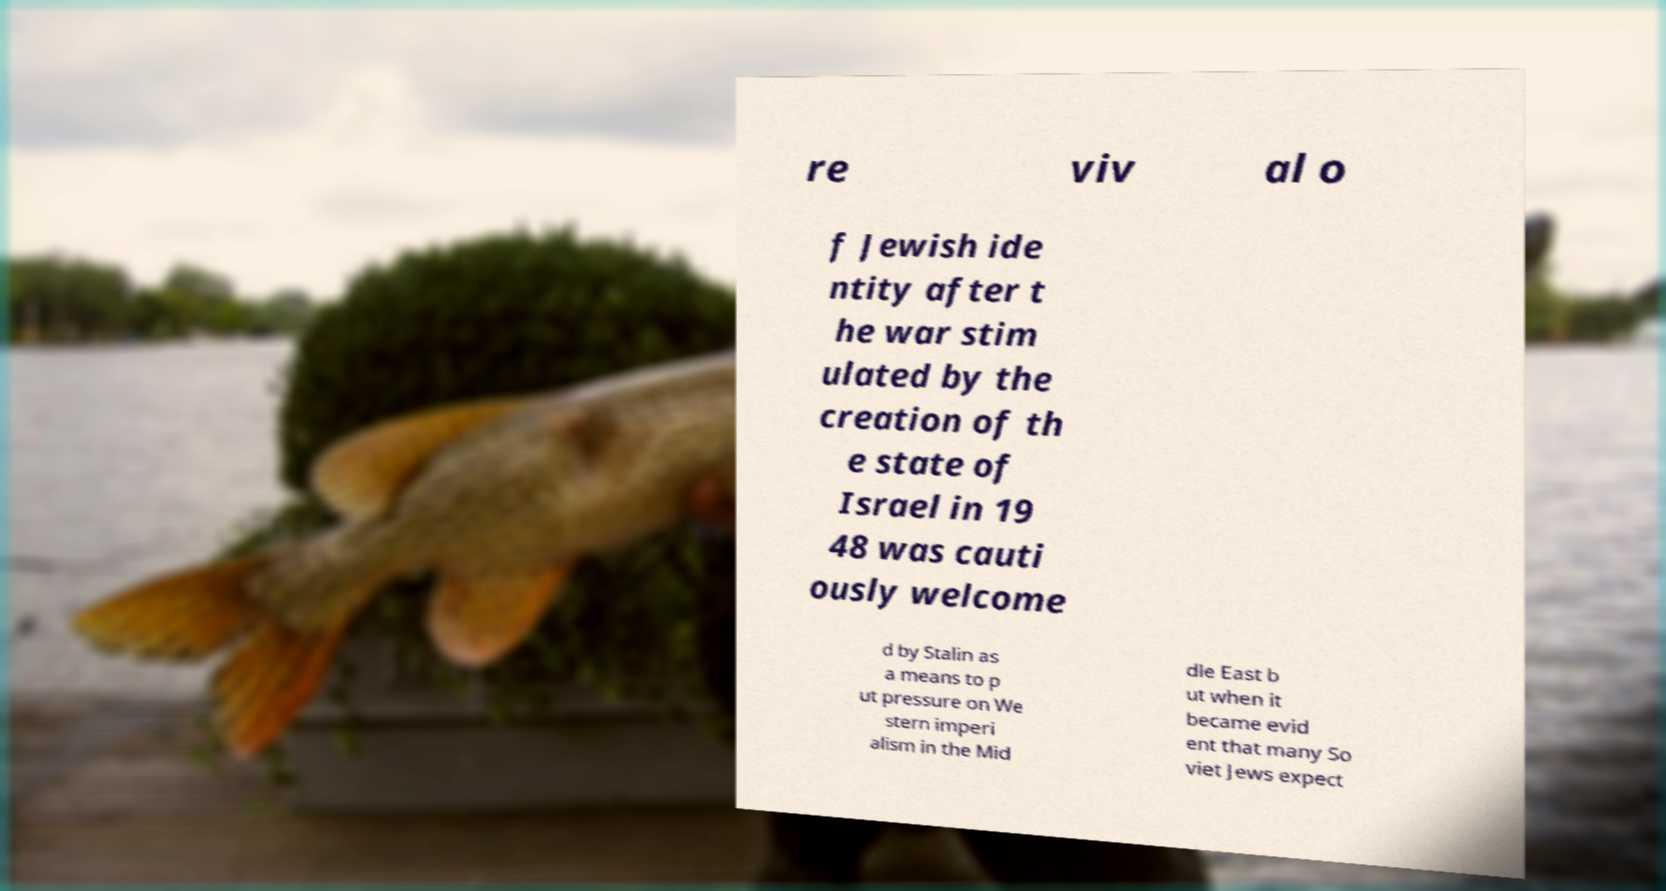Can you read and provide the text displayed in the image?This photo seems to have some interesting text. Can you extract and type it out for me? re viv al o f Jewish ide ntity after t he war stim ulated by the creation of th e state of Israel in 19 48 was cauti ously welcome d by Stalin as a means to p ut pressure on We stern imperi alism in the Mid dle East b ut when it became evid ent that many So viet Jews expect 